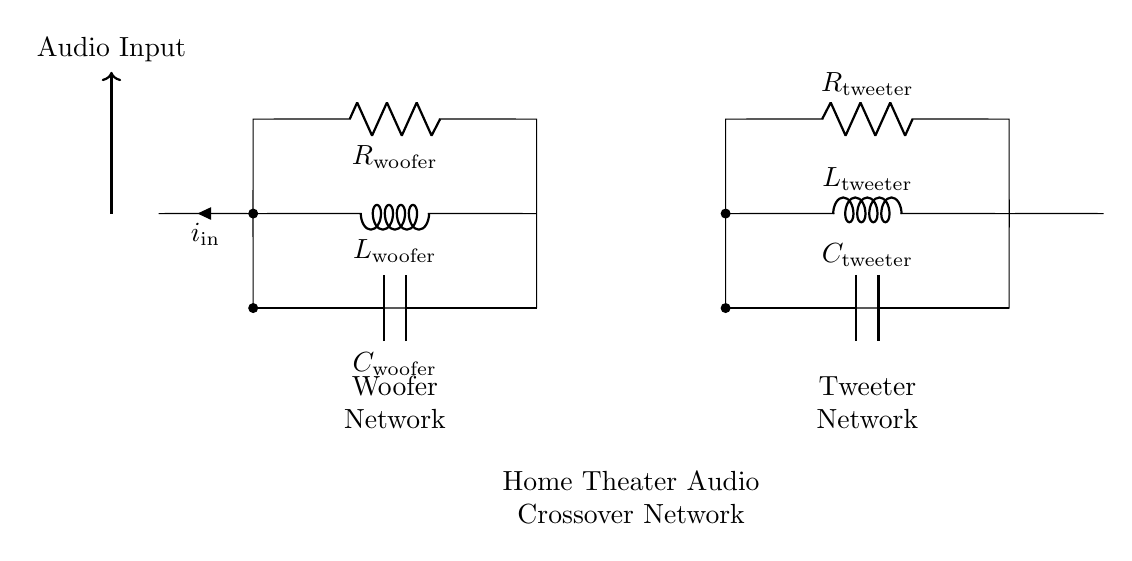What components are used in the tweeter network? The tweeter network consists of a resistor, an inductor, and a capacitor, specifically labeled as R_tweeter, L_tweeter, and C_tweeter in the diagram.
Answer: Resistor, inductor, capacitor What is the function of the capacitor in this circuit? The capacitor in the circuit serves to block low-frequency signals while allowing high-frequency signals to pass through, which is essential in audio crossover networks to separate frequency ranges.
Answer: Block low frequencies How many networks are shown in the circuit diagram? The diagram displays two networks: one for the woofer and one for the tweeter. This is represented by the two distinct sets of components labeled in the circuit.
Answer: Two Which component is responsible for filtering low frequencies in the woofer network? In the woofer network, the inductor L_woofer is primarily responsible for filtering low frequencies, as inductors resist changes in current and tend to pass lower frequencies while blocking higher ones.
Answer: L_woofer What is the relationship between the input current and the two networks? The input current i_in splits between the woofer and tweeter networks, with each network tuned to a different frequency range, forming a parallel RLC arrangement essential for the crossover function.
Answer: Splits into woofer and tweeter What role does the resistor play in the crossover network? The resistors R_tweeter and R_woofer help to control the amplitude of the signals, providing damping that stabilizes the response of the system and helps to achieve a smoother frequency transition.
Answer: Control signal amplitude 